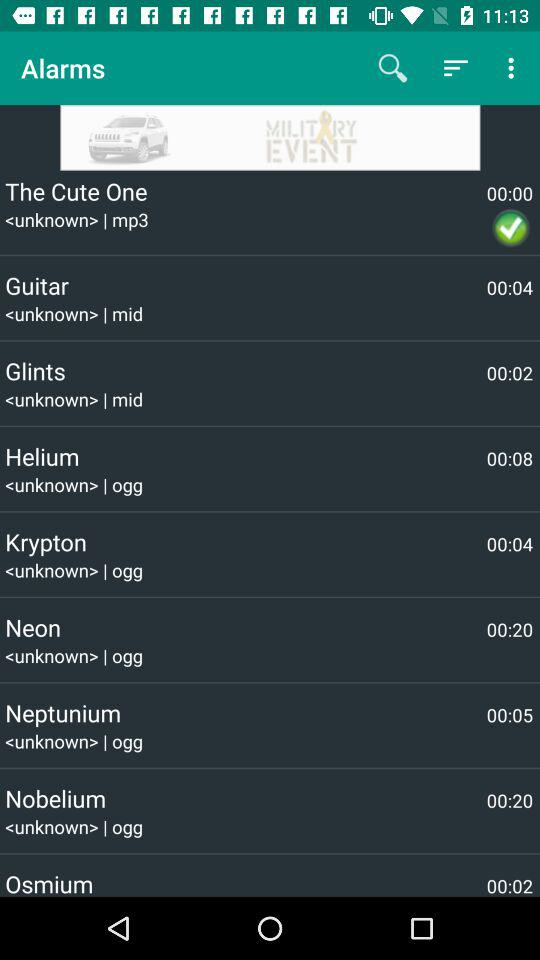Which alarm tone has the longest duration?
When the provided information is insufficient, respond with <no answer>. <no answer> 